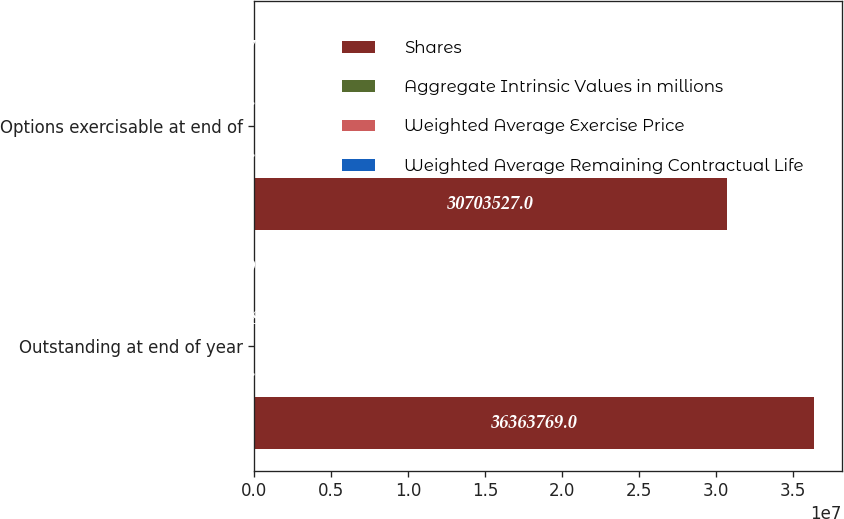<chart> <loc_0><loc_0><loc_500><loc_500><stacked_bar_chart><ecel><fcel>Outstanding at end of year<fcel>Options exercisable at end of<nl><fcel>Shares<fcel>3.63638e+07<fcel>3.07035e+07<nl><fcel>Aggregate Intrinsic Values in millions<fcel>63.83<fcel>63.98<nl><fcel>Weighted Average Exercise Price<fcel>4.81<fcel>4.1<nl><fcel>Weighted Average Remaining Contractual Life<fcel>59<fcel>57<nl></chart> 